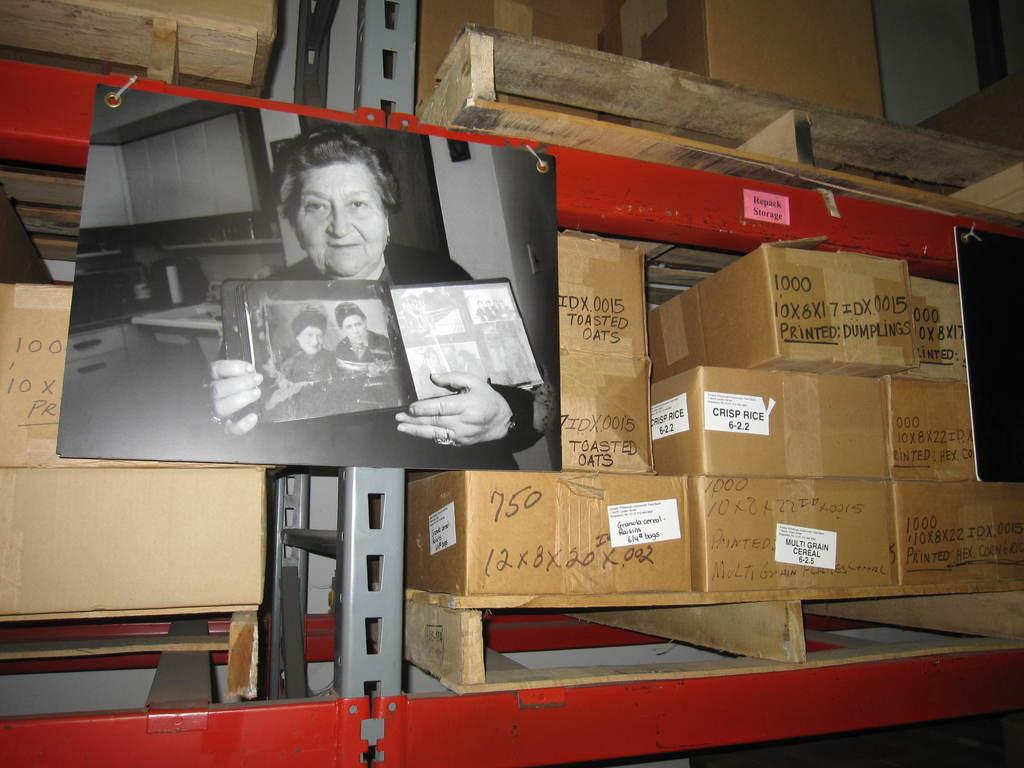Provide a one-sentence caption for the provided image. A box has the words toasted oats written on it in black marker. 